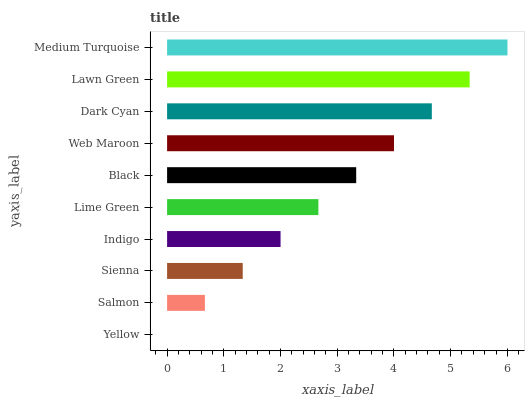Is Yellow the minimum?
Answer yes or no. Yes. Is Medium Turquoise the maximum?
Answer yes or no. Yes. Is Salmon the minimum?
Answer yes or no. No. Is Salmon the maximum?
Answer yes or no. No. Is Salmon greater than Yellow?
Answer yes or no. Yes. Is Yellow less than Salmon?
Answer yes or no. Yes. Is Yellow greater than Salmon?
Answer yes or no. No. Is Salmon less than Yellow?
Answer yes or no. No. Is Black the high median?
Answer yes or no. Yes. Is Lime Green the low median?
Answer yes or no. Yes. Is Medium Turquoise the high median?
Answer yes or no. No. Is Indigo the low median?
Answer yes or no. No. 